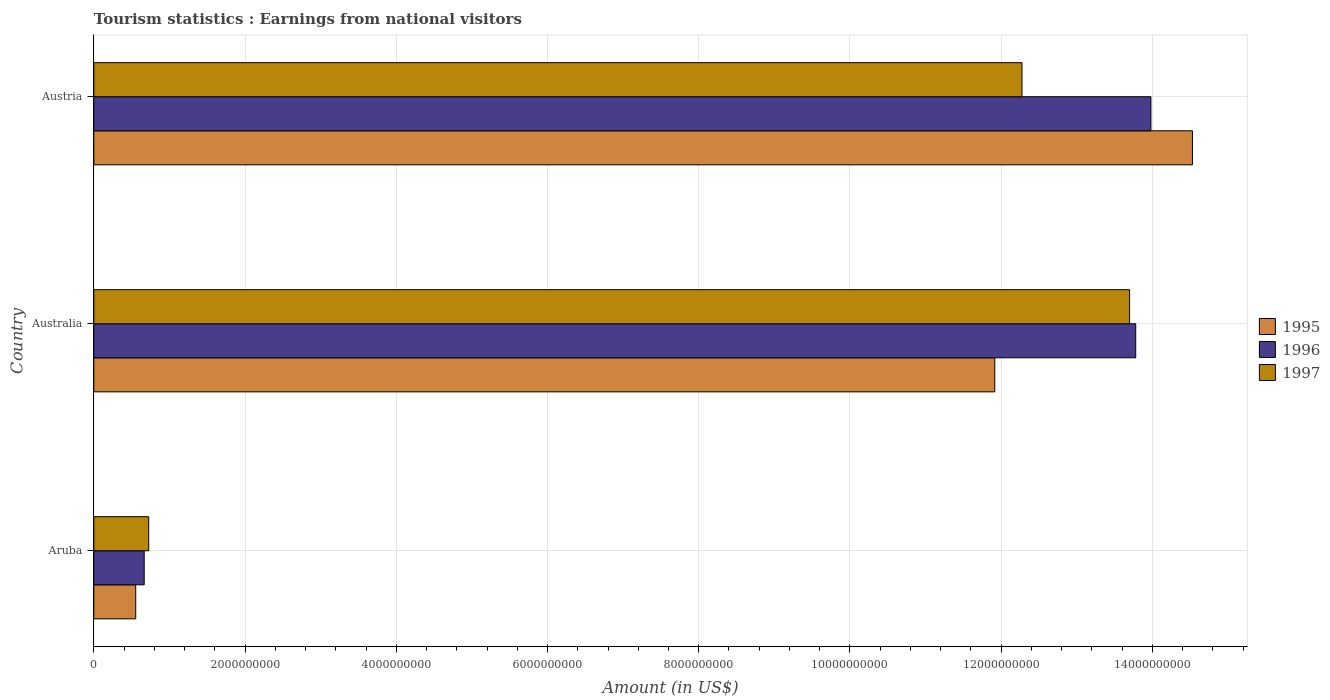How many different coloured bars are there?
Provide a succinct answer. 3. How many groups of bars are there?
Ensure brevity in your answer.  3. Are the number of bars per tick equal to the number of legend labels?
Provide a succinct answer. Yes. How many bars are there on the 2nd tick from the bottom?
Offer a terse response. 3. What is the label of the 3rd group of bars from the top?
Make the answer very short. Aruba. What is the earnings from national visitors in 1996 in Australia?
Keep it short and to the point. 1.38e+1. Across all countries, what is the maximum earnings from national visitors in 1996?
Ensure brevity in your answer.  1.40e+1. Across all countries, what is the minimum earnings from national visitors in 1997?
Provide a short and direct response. 7.26e+08. In which country was the earnings from national visitors in 1995 minimum?
Offer a terse response. Aruba. What is the total earnings from national visitors in 1995 in the graph?
Ensure brevity in your answer.  2.70e+1. What is the difference between the earnings from national visitors in 1995 in Aruba and that in Austria?
Give a very brief answer. -1.40e+1. What is the difference between the earnings from national visitors in 1996 in Aruba and the earnings from national visitors in 1997 in Austria?
Your answer should be very brief. -1.16e+1. What is the average earnings from national visitors in 1997 per country?
Offer a terse response. 8.90e+09. What is the difference between the earnings from national visitors in 1995 and earnings from national visitors in 1996 in Austria?
Offer a terse response. 5.49e+08. In how many countries, is the earnings from national visitors in 1996 greater than 4000000000 US$?
Your answer should be very brief. 2. What is the ratio of the earnings from national visitors in 1995 in Australia to that in Austria?
Keep it short and to the point. 0.82. Is the earnings from national visitors in 1996 in Aruba less than that in Australia?
Make the answer very short. Yes. What is the difference between the highest and the second highest earnings from national visitors in 1997?
Provide a succinct answer. 1.42e+09. What is the difference between the highest and the lowest earnings from national visitors in 1995?
Provide a succinct answer. 1.40e+1. In how many countries, is the earnings from national visitors in 1995 greater than the average earnings from national visitors in 1995 taken over all countries?
Your response must be concise. 2. Is the sum of the earnings from national visitors in 1996 in Aruba and Australia greater than the maximum earnings from national visitors in 1997 across all countries?
Your answer should be very brief. Yes. What does the 2nd bar from the bottom in Austria represents?
Your answer should be compact. 1996. Is it the case that in every country, the sum of the earnings from national visitors in 1997 and earnings from national visitors in 1996 is greater than the earnings from national visitors in 1995?
Give a very brief answer. Yes. What is the difference between two consecutive major ticks on the X-axis?
Your response must be concise. 2.00e+09. Are the values on the major ticks of X-axis written in scientific E-notation?
Ensure brevity in your answer.  No. Does the graph contain any zero values?
Your response must be concise. No. What is the title of the graph?
Ensure brevity in your answer.  Tourism statistics : Earnings from national visitors. What is the Amount (in US$) of 1995 in Aruba?
Your response must be concise. 5.54e+08. What is the Amount (in US$) of 1996 in Aruba?
Keep it short and to the point. 6.66e+08. What is the Amount (in US$) of 1997 in Aruba?
Your answer should be compact. 7.26e+08. What is the Amount (in US$) in 1995 in Australia?
Your answer should be compact. 1.19e+1. What is the Amount (in US$) in 1996 in Australia?
Your answer should be very brief. 1.38e+1. What is the Amount (in US$) of 1997 in Australia?
Offer a terse response. 1.37e+1. What is the Amount (in US$) of 1995 in Austria?
Make the answer very short. 1.45e+1. What is the Amount (in US$) in 1996 in Austria?
Your response must be concise. 1.40e+1. What is the Amount (in US$) in 1997 in Austria?
Make the answer very short. 1.23e+1. Across all countries, what is the maximum Amount (in US$) in 1995?
Offer a very short reply. 1.45e+1. Across all countries, what is the maximum Amount (in US$) of 1996?
Ensure brevity in your answer.  1.40e+1. Across all countries, what is the maximum Amount (in US$) of 1997?
Provide a succinct answer. 1.37e+1. Across all countries, what is the minimum Amount (in US$) in 1995?
Give a very brief answer. 5.54e+08. Across all countries, what is the minimum Amount (in US$) of 1996?
Ensure brevity in your answer.  6.66e+08. Across all countries, what is the minimum Amount (in US$) of 1997?
Your response must be concise. 7.26e+08. What is the total Amount (in US$) of 1995 in the graph?
Your answer should be compact. 2.70e+1. What is the total Amount (in US$) of 1996 in the graph?
Make the answer very short. 2.84e+1. What is the total Amount (in US$) of 1997 in the graph?
Offer a terse response. 2.67e+1. What is the difference between the Amount (in US$) of 1995 in Aruba and that in Australia?
Offer a very short reply. -1.14e+1. What is the difference between the Amount (in US$) in 1996 in Aruba and that in Australia?
Ensure brevity in your answer.  -1.31e+1. What is the difference between the Amount (in US$) of 1997 in Aruba and that in Australia?
Offer a terse response. -1.30e+1. What is the difference between the Amount (in US$) of 1995 in Aruba and that in Austria?
Offer a very short reply. -1.40e+1. What is the difference between the Amount (in US$) in 1996 in Aruba and that in Austria?
Your answer should be very brief. -1.33e+1. What is the difference between the Amount (in US$) of 1997 in Aruba and that in Austria?
Provide a short and direct response. -1.15e+1. What is the difference between the Amount (in US$) of 1995 in Australia and that in Austria?
Provide a short and direct response. -2.61e+09. What is the difference between the Amount (in US$) in 1996 in Australia and that in Austria?
Your response must be concise. -2.01e+08. What is the difference between the Amount (in US$) in 1997 in Australia and that in Austria?
Keep it short and to the point. 1.42e+09. What is the difference between the Amount (in US$) in 1995 in Aruba and the Amount (in US$) in 1996 in Australia?
Offer a very short reply. -1.32e+1. What is the difference between the Amount (in US$) of 1995 in Aruba and the Amount (in US$) of 1997 in Australia?
Provide a short and direct response. -1.31e+1. What is the difference between the Amount (in US$) in 1996 in Aruba and the Amount (in US$) in 1997 in Australia?
Your response must be concise. -1.30e+1. What is the difference between the Amount (in US$) in 1995 in Aruba and the Amount (in US$) in 1996 in Austria?
Make the answer very short. -1.34e+1. What is the difference between the Amount (in US$) of 1995 in Aruba and the Amount (in US$) of 1997 in Austria?
Provide a succinct answer. -1.17e+1. What is the difference between the Amount (in US$) of 1996 in Aruba and the Amount (in US$) of 1997 in Austria?
Your response must be concise. -1.16e+1. What is the difference between the Amount (in US$) of 1995 in Australia and the Amount (in US$) of 1996 in Austria?
Offer a very short reply. -2.06e+09. What is the difference between the Amount (in US$) in 1995 in Australia and the Amount (in US$) in 1997 in Austria?
Keep it short and to the point. -3.60e+08. What is the difference between the Amount (in US$) of 1996 in Australia and the Amount (in US$) of 1997 in Austria?
Provide a short and direct response. 1.50e+09. What is the average Amount (in US$) in 1995 per country?
Provide a succinct answer. 9.00e+09. What is the average Amount (in US$) in 1996 per country?
Your response must be concise. 9.48e+09. What is the average Amount (in US$) of 1997 per country?
Keep it short and to the point. 8.90e+09. What is the difference between the Amount (in US$) in 1995 and Amount (in US$) in 1996 in Aruba?
Your answer should be very brief. -1.12e+08. What is the difference between the Amount (in US$) of 1995 and Amount (in US$) of 1997 in Aruba?
Keep it short and to the point. -1.72e+08. What is the difference between the Amount (in US$) in 1996 and Amount (in US$) in 1997 in Aruba?
Give a very brief answer. -6.00e+07. What is the difference between the Amount (in US$) in 1995 and Amount (in US$) in 1996 in Australia?
Your answer should be compact. -1.86e+09. What is the difference between the Amount (in US$) of 1995 and Amount (in US$) of 1997 in Australia?
Offer a terse response. -1.78e+09. What is the difference between the Amount (in US$) in 1996 and Amount (in US$) in 1997 in Australia?
Your answer should be very brief. 8.10e+07. What is the difference between the Amount (in US$) of 1995 and Amount (in US$) of 1996 in Austria?
Provide a short and direct response. 5.49e+08. What is the difference between the Amount (in US$) of 1995 and Amount (in US$) of 1997 in Austria?
Give a very brief answer. 2.25e+09. What is the difference between the Amount (in US$) of 1996 and Amount (in US$) of 1997 in Austria?
Your response must be concise. 1.70e+09. What is the ratio of the Amount (in US$) in 1995 in Aruba to that in Australia?
Ensure brevity in your answer.  0.05. What is the ratio of the Amount (in US$) of 1996 in Aruba to that in Australia?
Your answer should be compact. 0.05. What is the ratio of the Amount (in US$) in 1997 in Aruba to that in Australia?
Provide a short and direct response. 0.05. What is the ratio of the Amount (in US$) in 1995 in Aruba to that in Austria?
Provide a short and direct response. 0.04. What is the ratio of the Amount (in US$) in 1996 in Aruba to that in Austria?
Offer a very short reply. 0.05. What is the ratio of the Amount (in US$) of 1997 in Aruba to that in Austria?
Your answer should be compact. 0.06. What is the ratio of the Amount (in US$) of 1995 in Australia to that in Austria?
Your answer should be very brief. 0.82. What is the ratio of the Amount (in US$) in 1996 in Australia to that in Austria?
Your answer should be compact. 0.99. What is the ratio of the Amount (in US$) of 1997 in Australia to that in Austria?
Ensure brevity in your answer.  1.12. What is the difference between the highest and the second highest Amount (in US$) of 1995?
Ensure brevity in your answer.  2.61e+09. What is the difference between the highest and the second highest Amount (in US$) of 1996?
Give a very brief answer. 2.01e+08. What is the difference between the highest and the second highest Amount (in US$) of 1997?
Your answer should be very brief. 1.42e+09. What is the difference between the highest and the lowest Amount (in US$) of 1995?
Give a very brief answer. 1.40e+1. What is the difference between the highest and the lowest Amount (in US$) in 1996?
Provide a succinct answer. 1.33e+1. What is the difference between the highest and the lowest Amount (in US$) of 1997?
Provide a short and direct response. 1.30e+1. 